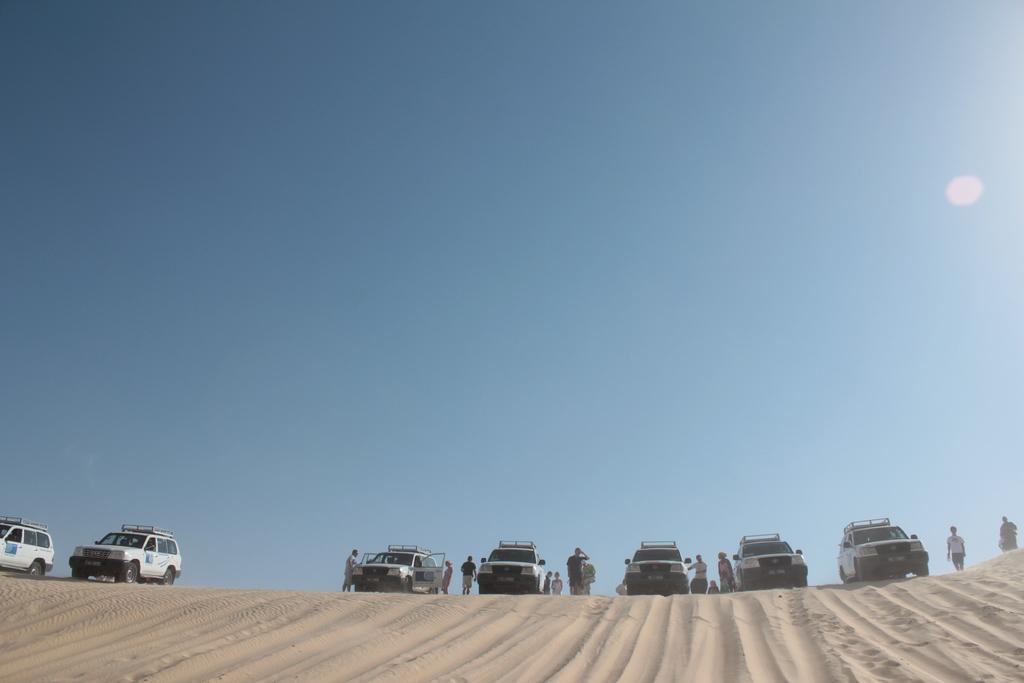What type of vehicles can be seen in the image? There are cars in the image. Are there any people present in the image? Yes, there are people in the image. What is the condition of the ground in the image? The floor appears to be muddy. What celestial body can be seen in the sky in the image? The moon is visible in the sky. What color is the orange being used for the volleyball game in the image? There is no orange or volleyball game present in the image. What is the level of interest in the image? The level of interest cannot be determined from the image alone, as it depends on the viewer's perspective. 